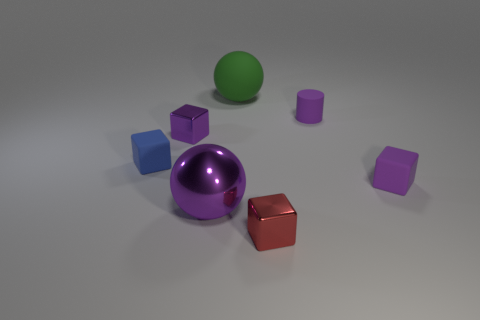Do the green rubber object and the large purple metallic thing have the same shape? While both the green rubber object and the large purple metallic thing share a rounded contour, the green object is a sphere and the purple object is a curved-sided shape with a circular base, presumably a cylinder. Therefore, while they exhibit similarities in their curvature, they do not have the same geometrical shape. 